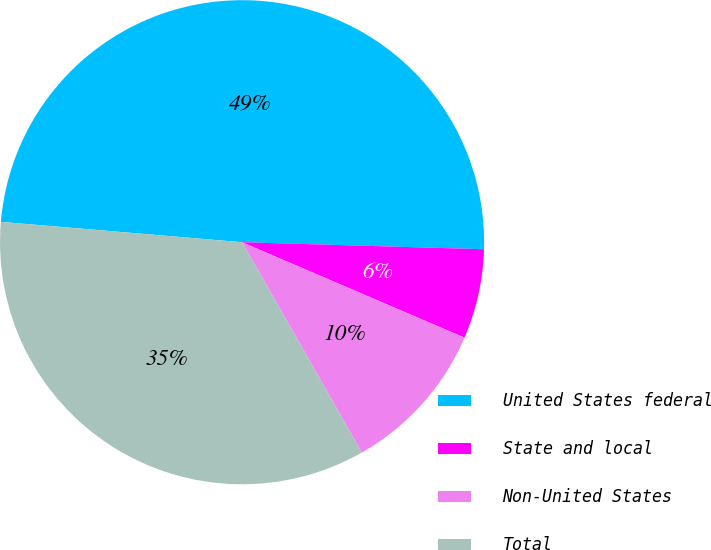<chart> <loc_0><loc_0><loc_500><loc_500><pie_chart><fcel>United States federal<fcel>State and local<fcel>Non-United States<fcel>Total<nl><fcel>49.12%<fcel>5.99%<fcel>10.31%<fcel>34.58%<nl></chart> 